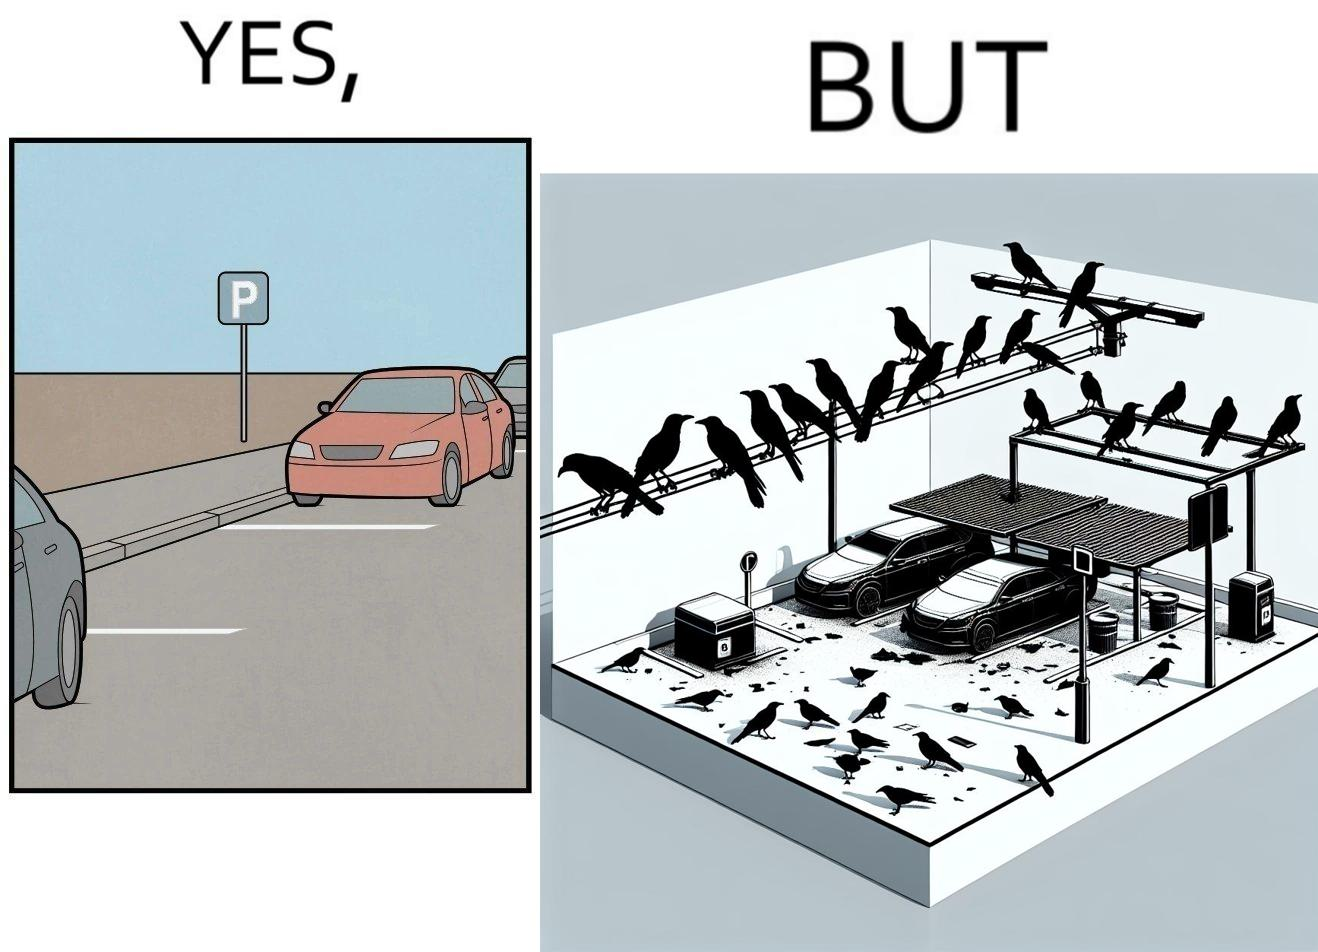What is the satirical meaning behind this image? The image is ironical such that although there is a place for parking but that place is not suitable because if we place our car there then our car will become dirty from top due to crow beet. 